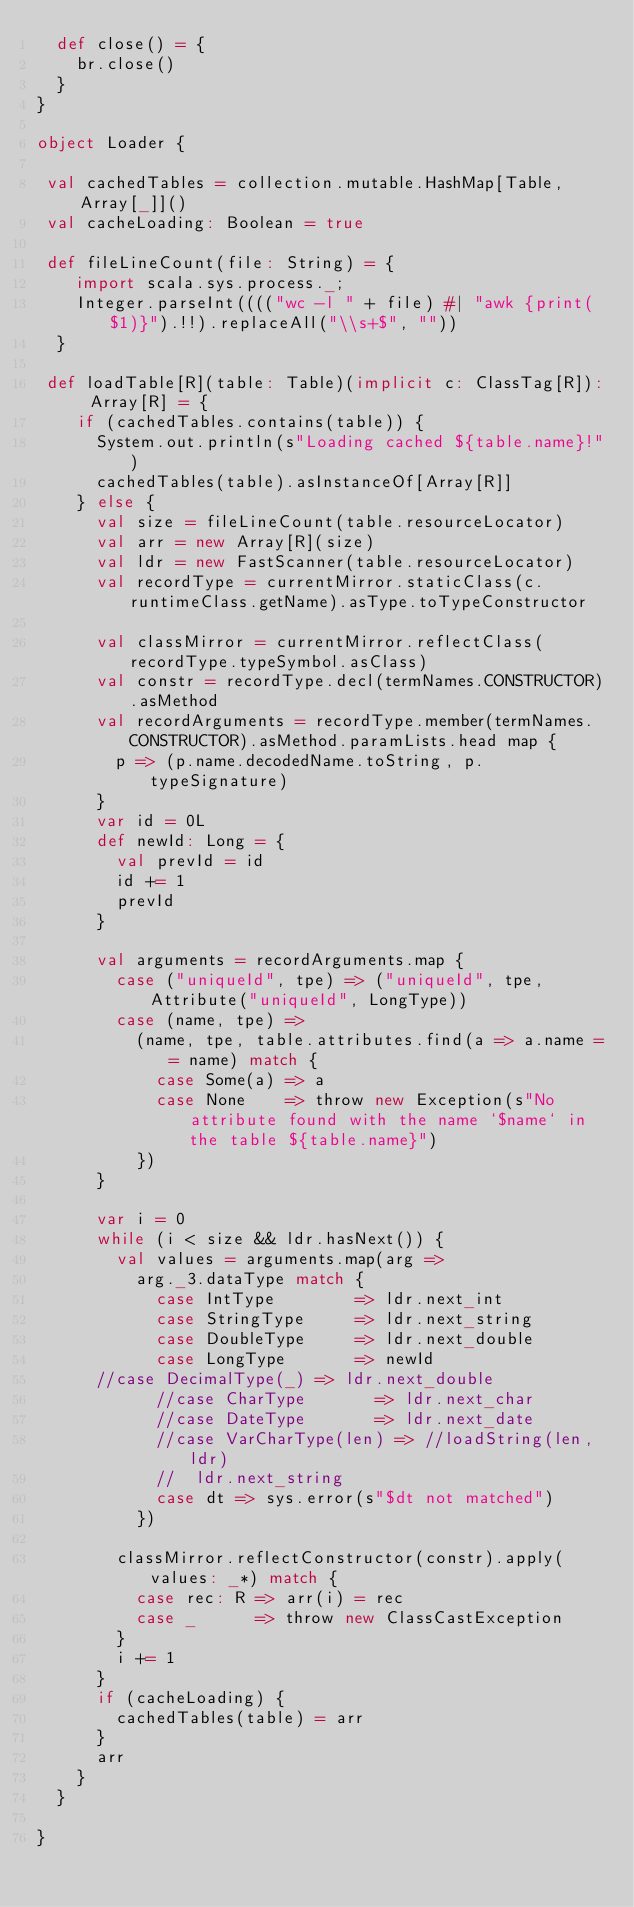Convert code to text. <code><loc_0><loc_0><loc_500><loc_500><_Scala_>  def close() = {
    br.close()
  }
}

object Loader {

 val cachedTables = collection.mutable.HashMap[Table, Array[_]]()
 val cacheLoading: Boolean = true
 
 def fileLineCount(file: String) = {
    import scala.sys.process._;
    Integer.parseInt(((("wc -l " + file) #| "awk {print($1)}").!!).replaceAll("\\s+$", ""))
  }

 def loadTable[R](table: Table)(implicit c: ClassTag[R]): Array[R] = {
    if (cachedTables.contains(table)) {
      System.out.println(s"Loading cached ${table.name}!")
      cachedTables(table).asInstanceOf[Array[R]]
    } else {
      val size = fileLineCount(table.resourceLocator)
      val arr = new Array[R](size)
      val ldr = new FastScanner(table.resourceLocator)
      val recordType = currentMirror.staticClass(c.runtimeClass.getName).asType.toTypeConstructor

      val classMirror = currentMirror.reflectClass(recordType.typeSymbol.asClass)
      val constr = recordType.decl(termNames.CONSTRUCTOR).asMethod
      val recordArguments = recordType.member(termNames.CONSTRUCTOR).asMethod.paramLists.head map {
        p => (p.name.decodedName.toString, p.typeSignature)
      }
      var id = 0L
      def newId: Long = {
        val prevId = id
        id += 1
        prevId
      }

      val arguments = recordArguments.map {
        case ("uniqueId", tpe) => ("uniqueId", tpe, Attribute("uniqueId", LongType))
        case (name, tpe) =>
          (name, tpe, table.attributes.find(a => a.name == name) match {
            case Some(a) => a
            case None    => throw new Exception(s"No attribute found with the name `$name` in the table ${table.name}")
          })
      }

      var i = 0
      while (i < size && ldr.hasNext()) {
        val values = arguments.map(arg =>
          arg._3.dataType match {
            case IntType        => ldr.next_int
            case StringType     => ldr.next_string
            case DoubleType     => ldr.next_double
            case LongType       => newId
	    //case DecimalType(_) => ldr.next_double
            //case CharType       => ldr.next_char
            //case DateType       => ldr.next_date
            //case VarCharType(len) => //loadString(len, ldr)
            //  ldr.next_string
            case dt => sys.error(s"$dt not matched")
          })

        classMirror.reflectConstructor(constr).apply(values: _*) match {
          case rec: R => arr(i) = rec
          case _      => throw new ClassCastException
        }
        i += 1
      }
      if (cacheLoading) {
        cachedTables(table) = arr
      }
      arr
    }
  }

}
</code> 